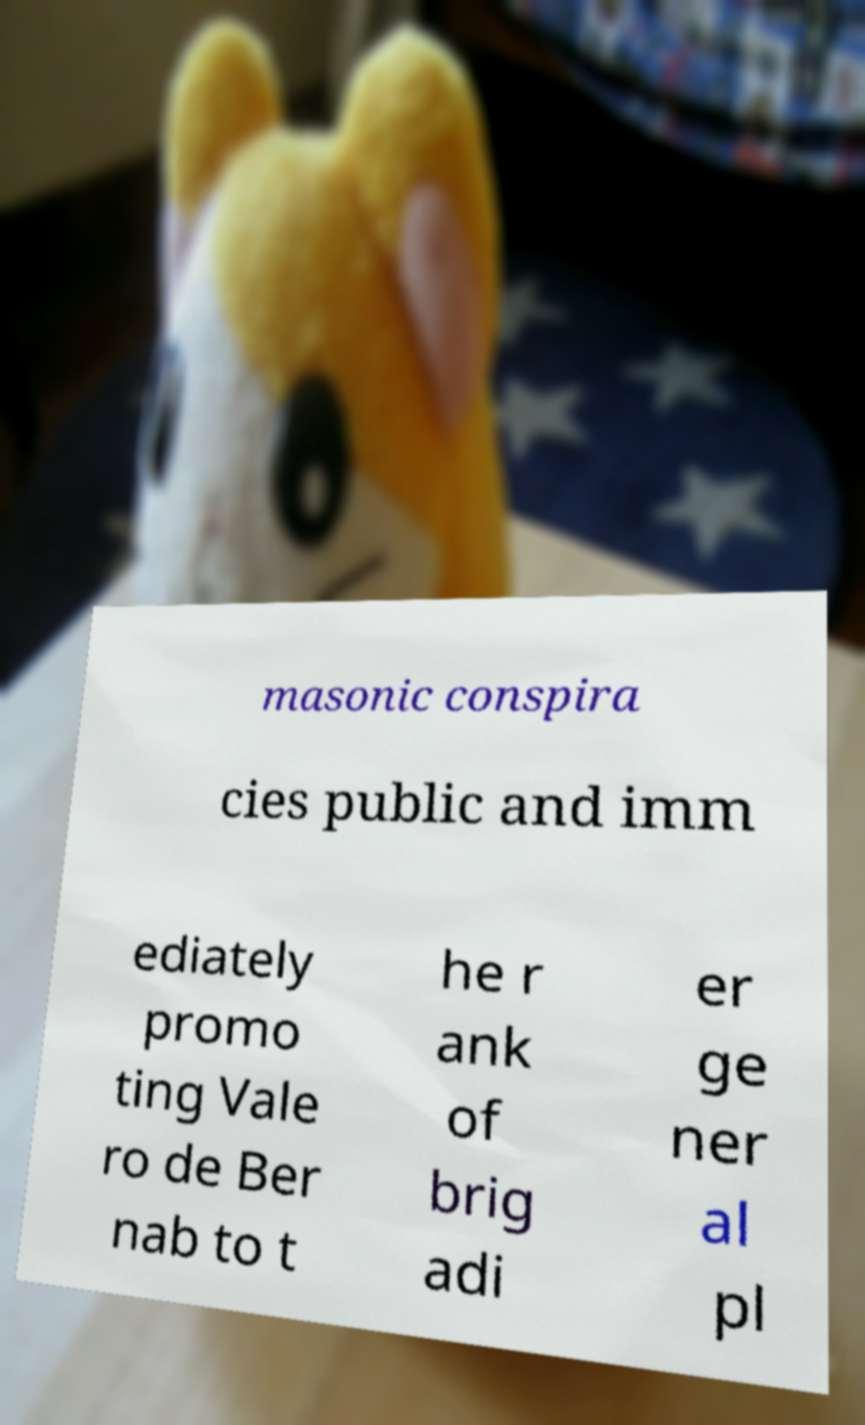Could you extract and type out the text from this image? masonic conspira cies public and imm ediately promo ting Vale ro de Ber nab to t he r ank of brig adi er ge ner al pl 